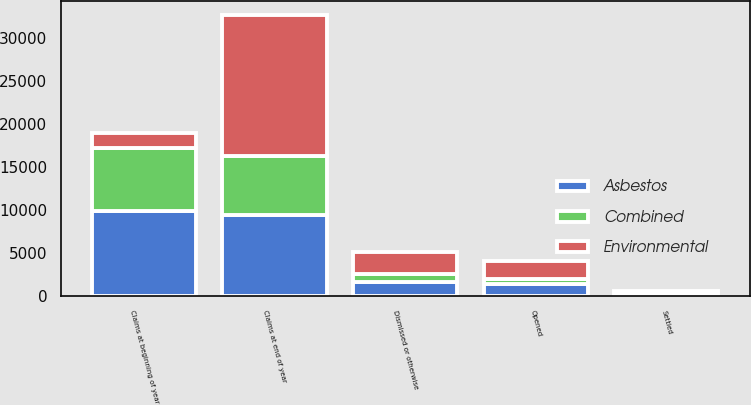Convert chart. <chart><loc_0><loc_0><loc_500><loc_500><stacked_bar_chart><ecel><fcel>Claims at beginning of year<fcel>Opened<fcel>Settled<fcel>Dismissed or otherwise<fcel>Claims at end of year<nl><fcel>Combined<fcel>7293<fcel>643<fcel>150<fcel>908<fcel>6878<nl><fcel>Asbestos<fcel>9873<fcel>1383<fcel>155<fcel>1659<fcel>9442<nl><fcel>Environmental<fcel>1842.5<fcel>2026<fcel>305<fcel>2567<fcel>16320<nl></chart> 